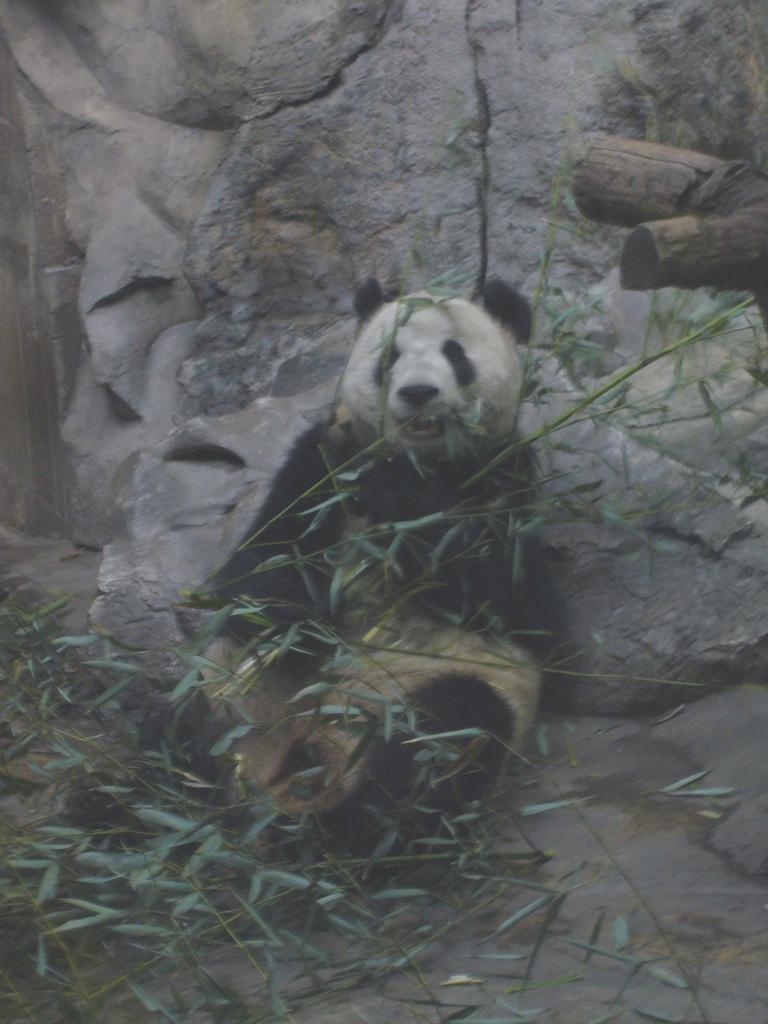What animal is present in the image? There is a panda in the image. What type of vegetation can be seen in the image? There are plants in the image. What can be seen in the background of the image? There is a rock in the background of the image. What is on the right side of the image? There is a tree trunk on the right side of the image. How many sticks does the beggar have in the image? There is no beggar or stick present in the image. What type of chair can be seen in the image? There is no chair present in the image. 